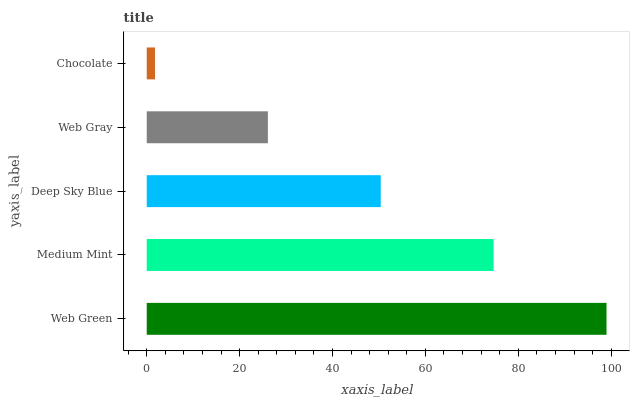Is Chocolate the minimum?
Answer yes or no. Yes. Is Web Green the maximum?
Answer yes or no. Yes. Is Medium Mint the minimum?
Answer yes or no. No. Is Medium Mint the maximum?
Answer yes or no. No. Is Web Green greater than Medium Mint?
Answer yes or no. Yes. Is Medium Mint less than Web Green?
Answer yes or no. Yes. Is Medium Mint greater than Web Green?
Answer yes or no. No. Is Web Green less than Medium Mint?
Answer yes or no. No. Is Deep Sky Blue the high median?
Answer yes or no. Yes. Is Deep Sky Blue the low median?
Answer yes or no. Yes. Is Web Gray the high median?
Answer yes or no. No. Is Chocolate the low median?
Answer yes or no. No. 